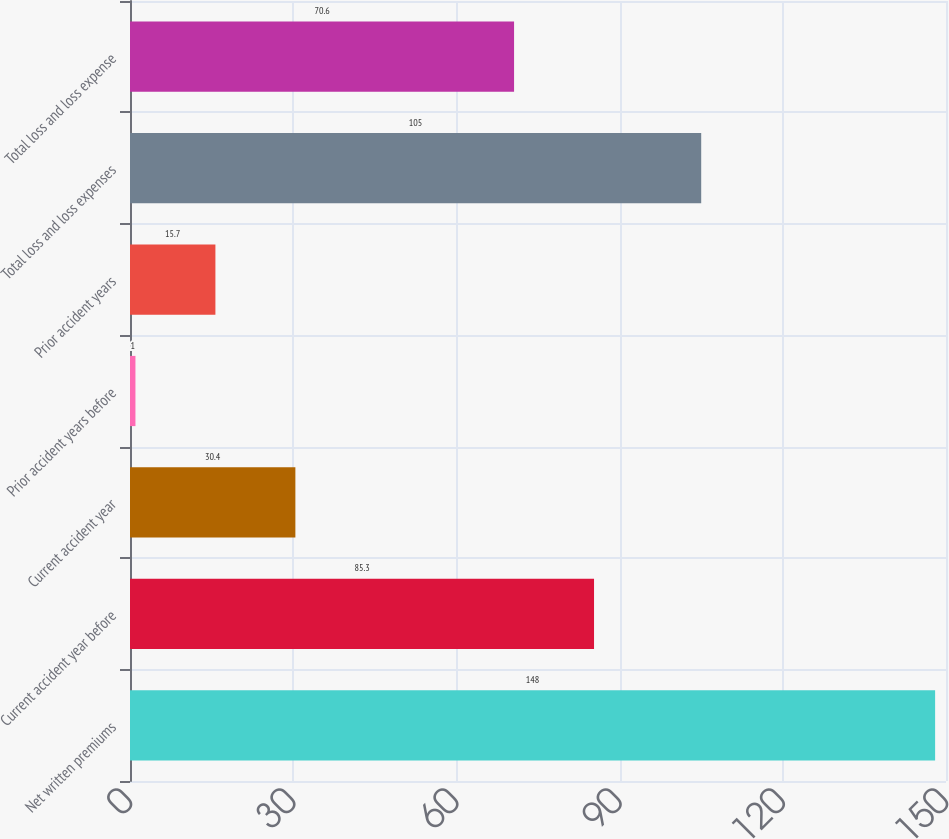<chart> <loc_0><loc_0><loc_500><loc_500><bar_chart><fcel>Net written premiums<fcel>Current accident year before<fcel>Current accident year<fcel>Prior accident years before<fcel>Prior accident years<fcel>Total loss and loss expenses<fcel>Total loss and loss expense<nl><fcel>148<fcel>85.3<fcel>30.4<fcel>1<fcel>15.7<fcel>105<fcel>70.6<nl></chart> 